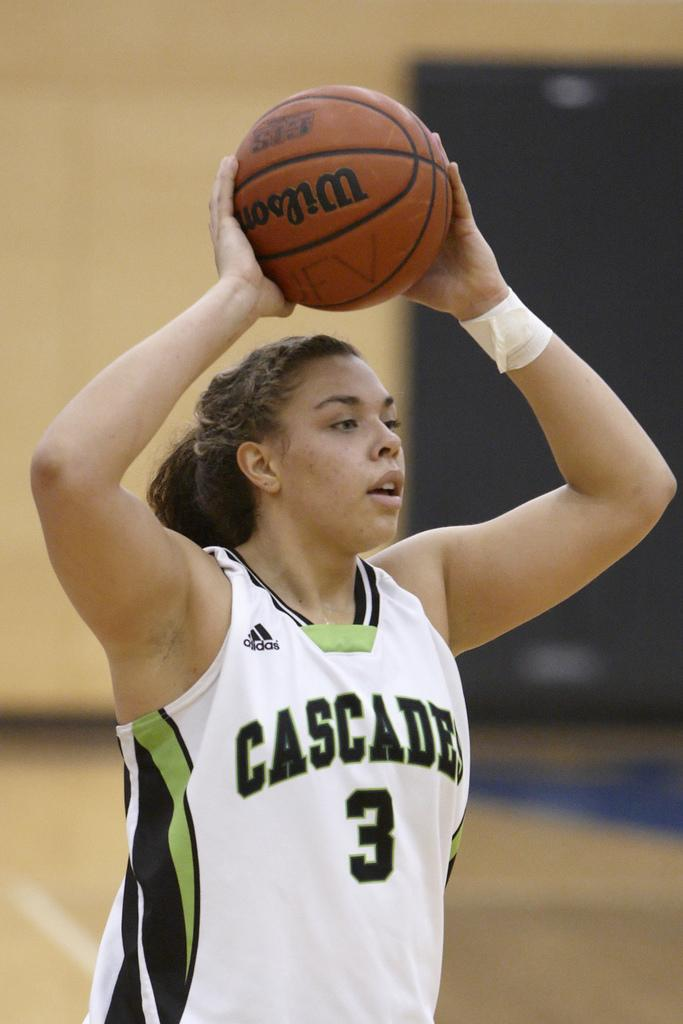<image>
Share a concise interpretation of the image provided. Basketball player for cascade is holding a basketball 